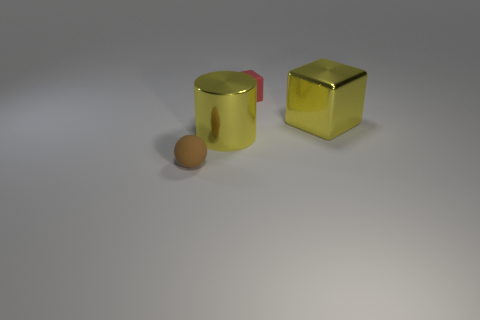Add 2 yellow shiny things. How many objects exist? 6 Subtract all cylinders. How many objects are left? 3 Add 3 tiny purple rubber cylinders. How many tiny purple rubber cylinders exist? 3 Subtract 0 brown cylinders. How many objects are left? 4 Subtract all big red matte objects. Subtract all large shiny cylinders. How many objects are left? 3 Add 2 large shiny cylinders. How many large shiny cylinders are left? 3 